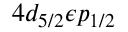<formula> <loc_0><loc_0><loc_500><loc_500>4 d _ { 5 / 2 } \epsilon p _ { 1 / 2 }</formula> 